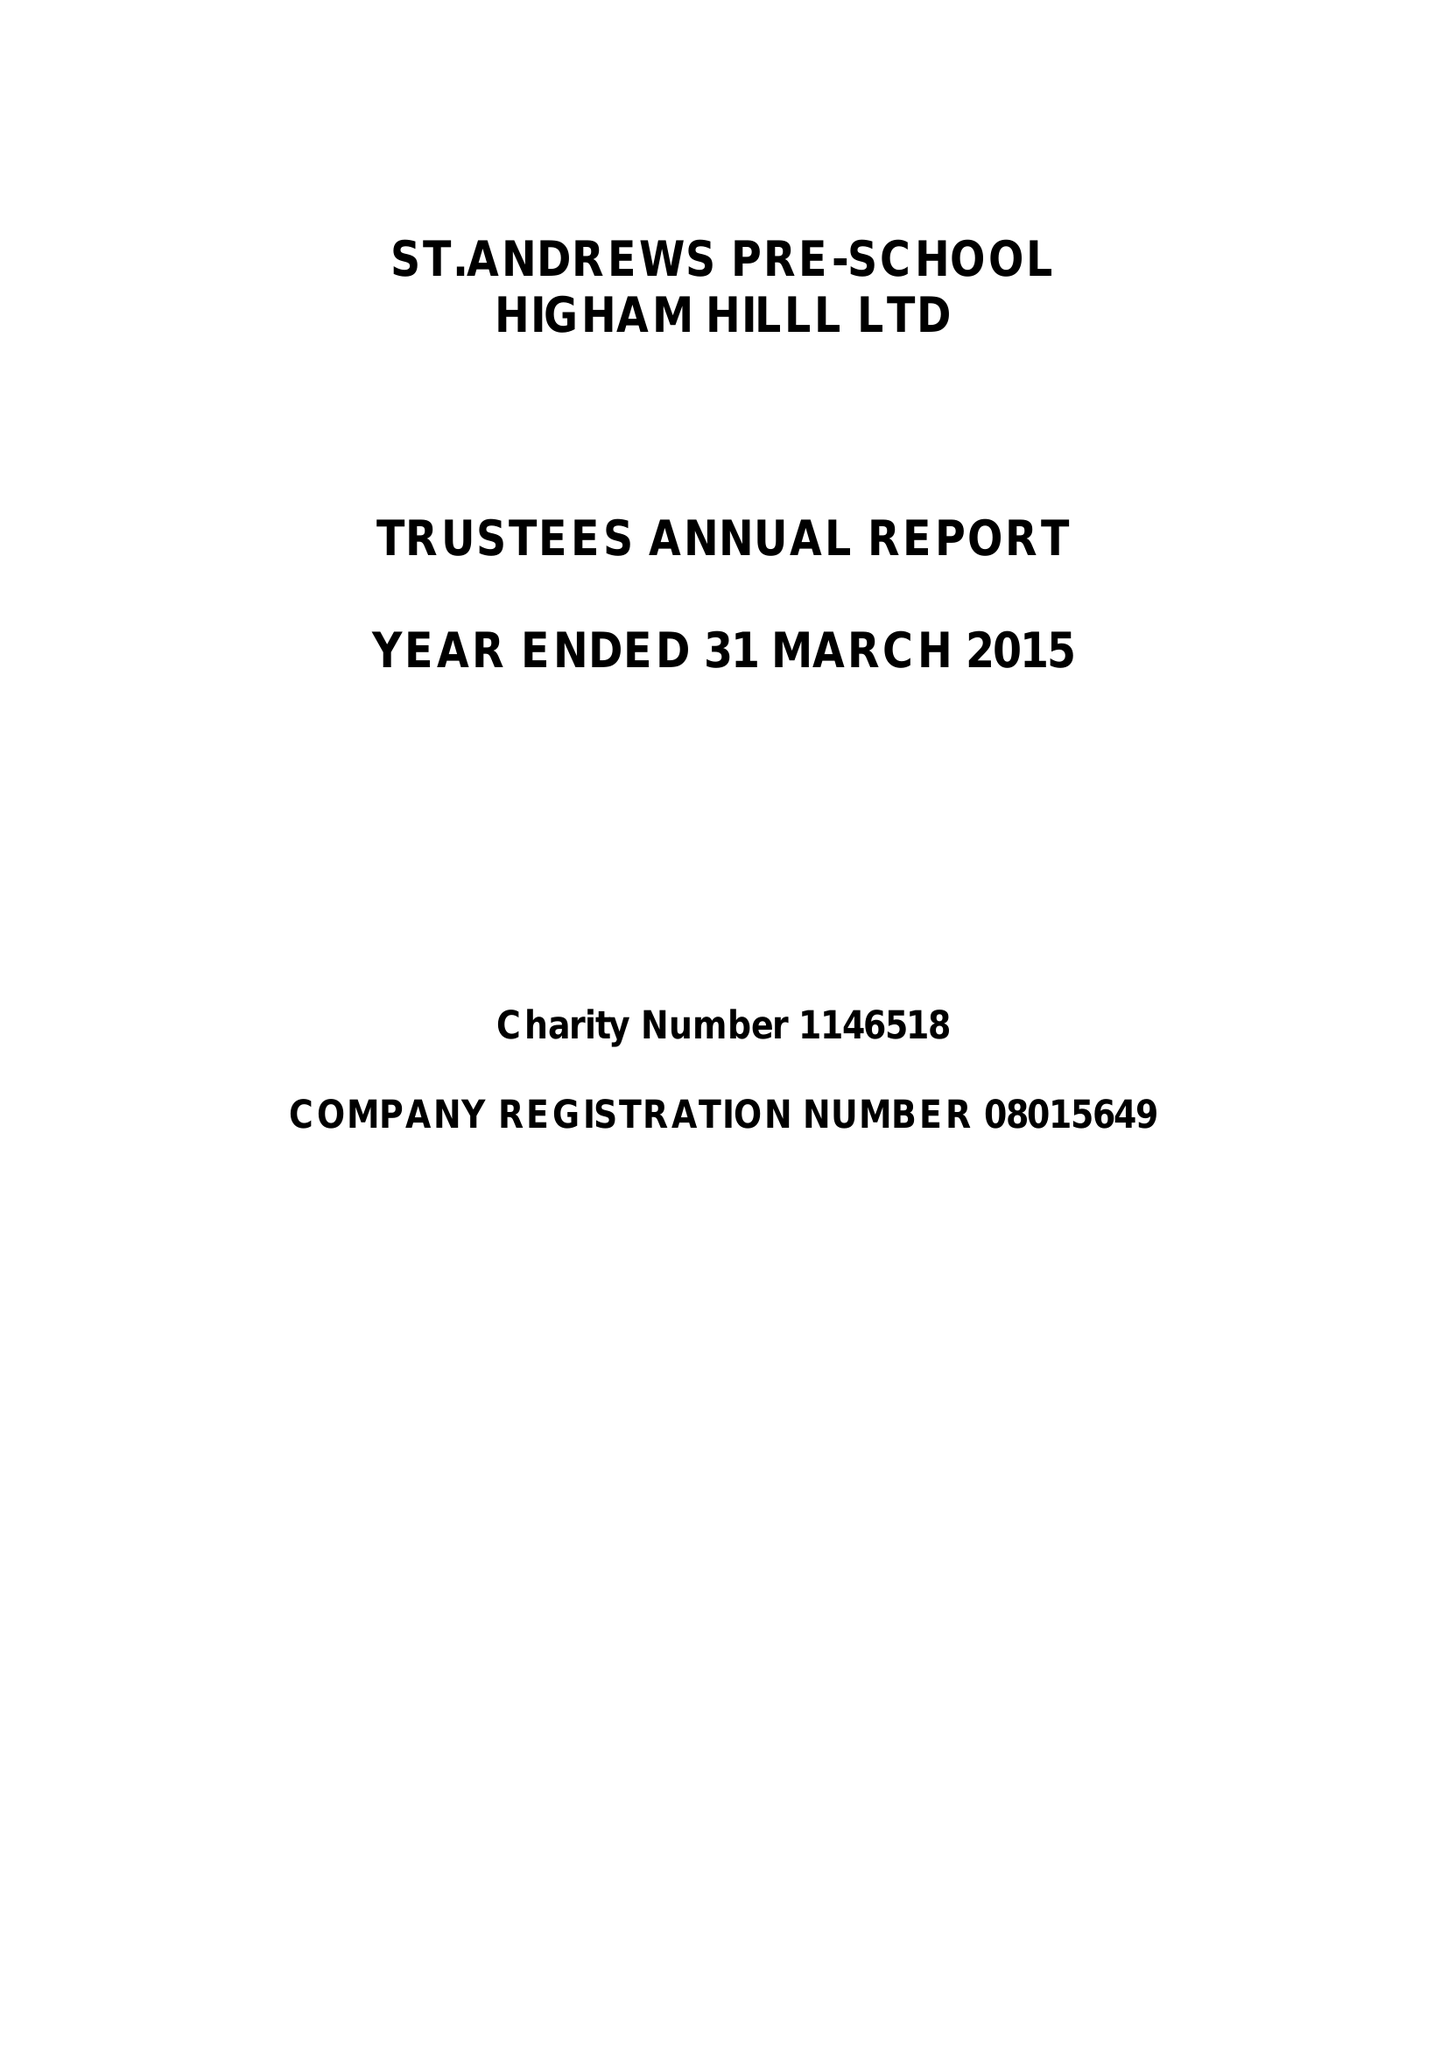What is the value for the charity_name?
Answer the question using a single word or phrase. St.Andrews Pre-School Higham Hill Ltd. 